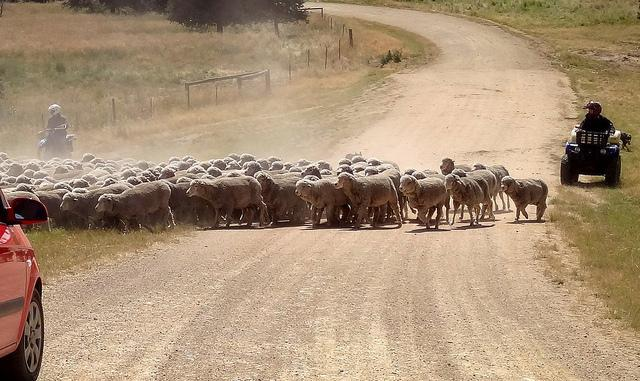Why are the sheep turning right?

Choices:
A) avoiding dust
B) eating grass
C) avoiding car
D) following motorcyclist avoiding car 